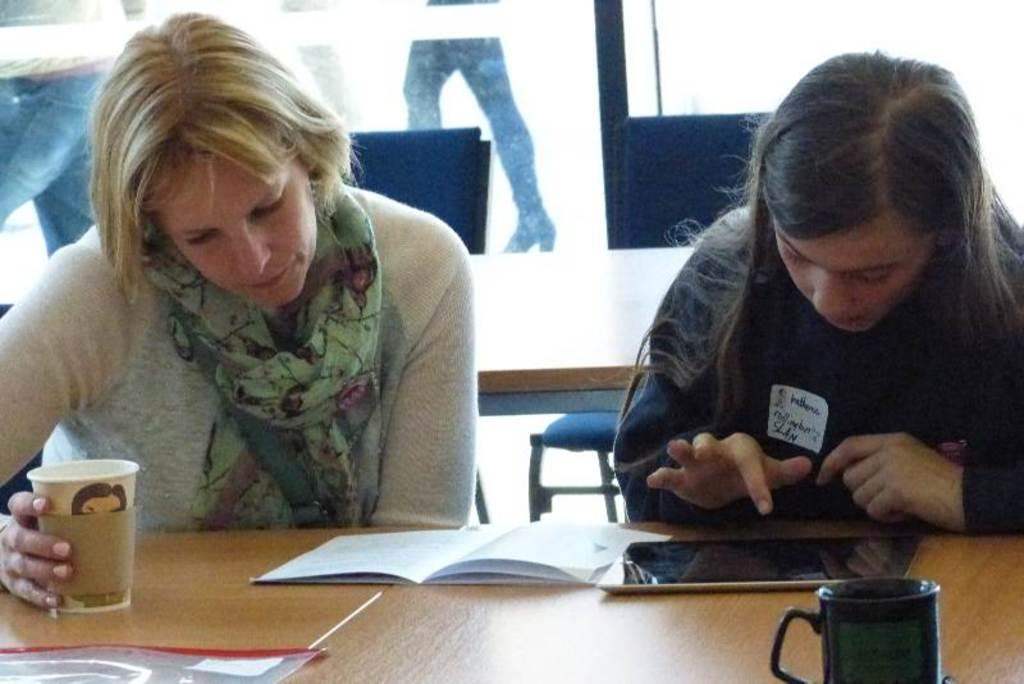How would you summarize this image in a sentence or two? There are two women sitting on a chair. One is playing with a mobile and the other woman is reading a book and she is holding a glass in her hand. 